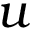<formula> <loc_0><loc_0><loc_500><loc_500>u</formula> 